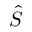Convert formula to latex. <formula><loc_0><loc_0><loc_500><loc_500>\hat { S }</formula> 